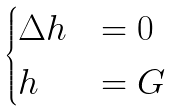Convert formula to latex. <formula><loc_0><loc_0><loc_500><loc_500>\begin{cases} \Delta h & = 0 \quad \\ h & = G \quad \end{cases}</formula> 